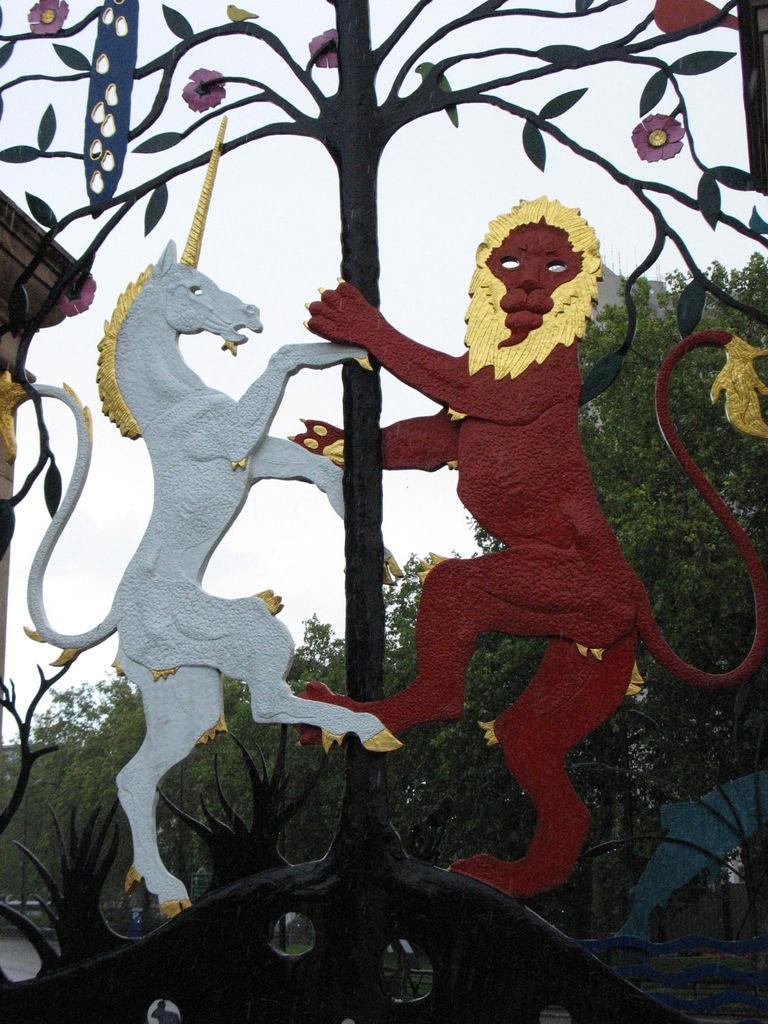What is the main object in the image? There is a gate in the image. What can be seen on the gate? The gate has a design of animals. What type of natural environment is visible in the background of the image? There are trees in the background of the image. What is visible above the trees in the image? The sky is visible in the background of the image. What is the price of the nose in the image? There is no nose present in the image, so it is not possible to determine its price. 